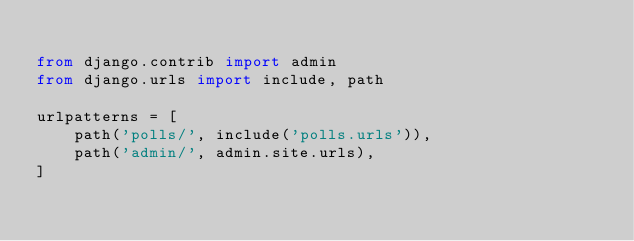<code> <loc_0><loc_0><loc_500><loc_500><_Python_>
from django.contrib import admin
from django.urls import include, path

urlpatterns = [
    path('polls/', include('polls.urls')),
    path('admin/', admin.site.urls),
]
</code> 